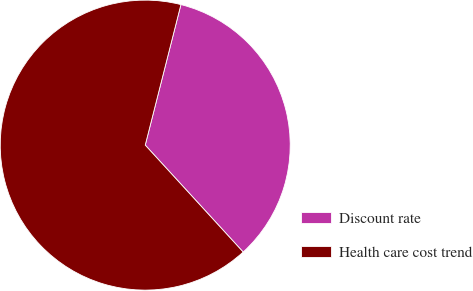Convert chart. <chart><loc_0><loc_0><loc_500><loc_500><pie_chart><fcel>Discount rate<fcel>Health care cost trend<nl><fcel>34.24%<fcel>65.76%<nl></chart> 